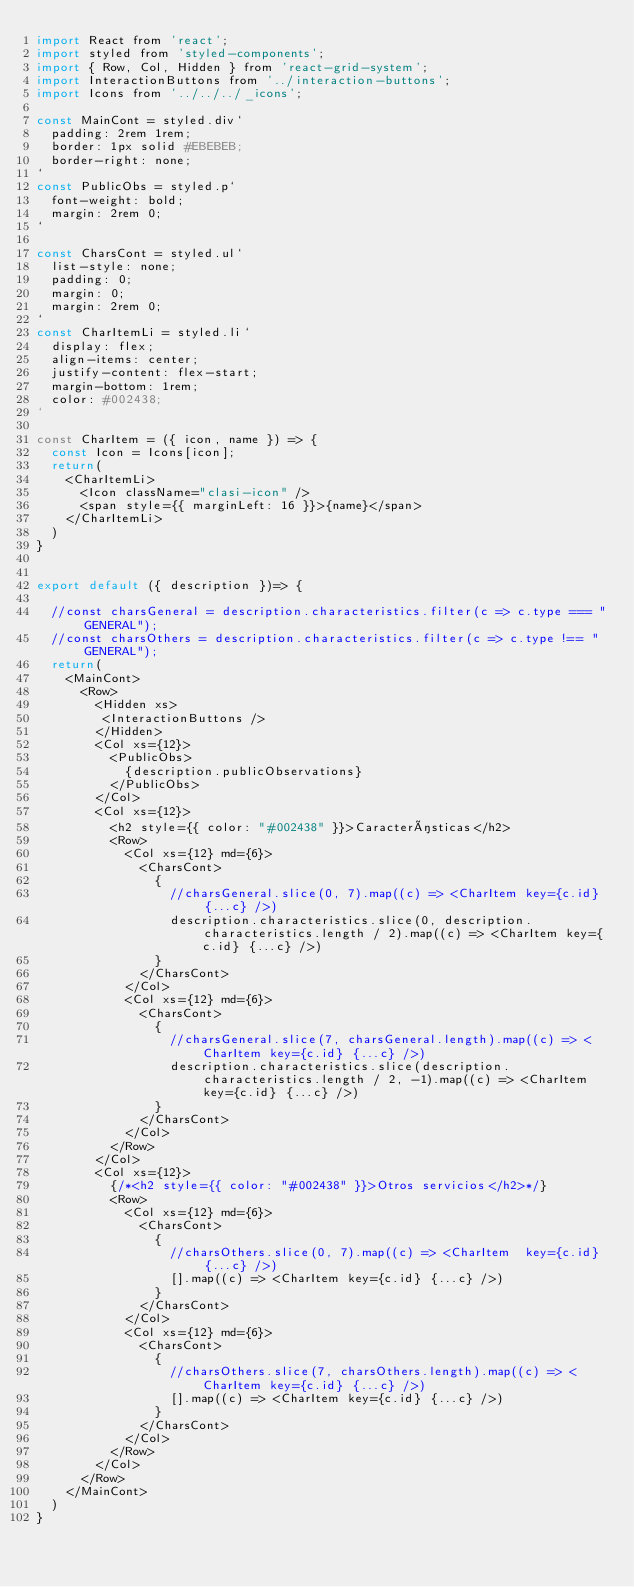Convert code to text. <code><loc_0><loc_0><loc_500><loc_500><_JavaScript_>import React from 'react';
import styled from 'styled-components';
import { Row, Col, Hidden } from 'react-grid-system';
import InteractionButtons from '../interaction-buttons';
import Icons from '../../../_icons';

const MainCont = styled.div`
  padding: 2rem 1rem;
  border: 1px solid #EBEBEB;
  border-right: none;
`
const PublicObs = styled.p`
  font-weight: bold;
  margin: 2rem 0;
`

const CharsCont = styled.ul`
  list-style: none;
  padding: 0;
  margin: 0;
  margin: 2rem 0;
`
const CharItemLi = styled.li`
  display: flex;
  align-items: center;
  justify-content: flex-start;
  margin-bottom: 1rem;
  color: #002438;
`

const CharItem = ({ icon, name }) => {
  const Icon = Icons[icon];
  return(
    <CharItemLi>
      <Icon className="clasi-icon" />
      <span style={{ marginLeft: 16 }}>{name}</span>
    </CharItemLi>
  )
}


export default ({ description })=> {

  //const charsGeneral = description.characteristics.filter(c => c.type === "GENERAL");
  //const charsOthers = description.characteristics.filter(c => c.type !== "GENERAL");
  return(
    <MainCont>
      <Row>
        <Hidden xs>
         <InteractionButtons />
        </Hidden>
        <Col xs={12}>
          <PublicObs>
            {description.publicObservations}              
          </PublicObs>
        </Col>
        <Col xs={12}>
          <h2 style={{ color: "#002438" }}>Características</h2>
          <Row>
            <Col xs={12} md={6}>
              <CharsCont>
                {
                  //charsGeneral.slice(0, 7).map((c) => <CharItem key={c.id} {...c} />)
                  description.characteristics.slice(0, description.characteristics.length / 2).map((c) => <CharItem key={c.id} {...c} />)
                }
              </CharsCont>
            </Col>
            <Col xs={12} md={6}>
              <CharsCont>
                {
                  //charsGeneral.slice(7, charsGeneral.length).map((c) => <CharItem key={c.id} {...c} />)
                  description.characteristics.slice(description.characteristics.length / 2, -1).map((c) => <CharItem key={c.id} {...c} />)
                }        
              </CharsCont>      
            </Col>            
          </Row>
        </Col>
        <Col xs={12}>
          {/*<h2 style={{ color: "#002438" }}>Otros servicios</h2>*/}
          <Row>
            <Col xs={12} md={6}>
              <CharsCont>
                {
                  //charsOthers.slice(0, 7).map((c) => <CharItem  key={c.id} {...c} />)
                  [].map((c) => <CharItem key={c.id} {...c} />)
                }
              </CharsCont>
            </Col>
            <Col xs={12} md={6}>
              <CharsCont>
                {
                  //charsOthers.slice(7, charsOthers.length).map((c) => <CharItem key={c.id} {...c} />)
                  [].map((c) => <CharItem key={c.id} {...c} />)
                }        
              </CharsCont>                    
            </Col>            
          </Row>
        </Col>        
      </Row>
    </MainCont>
  )
}</code> 